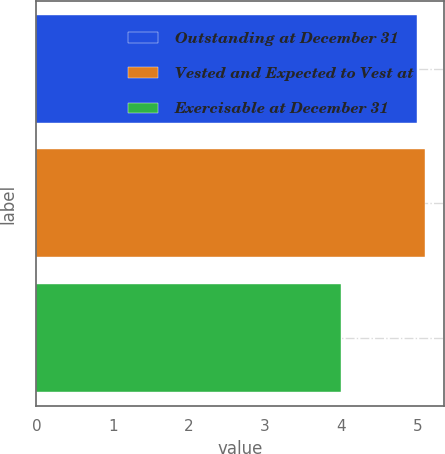Convert chart. <chart><loc_0><loc_0><loc_500><loc_500><bar_chart><fcel>Outstanding at December 31<fcel>Vested and Expected to Vest at<fcel>Exercisable at December 31<nl><fcel>5<fcel>5.1<fcel>4<nl></chart> 